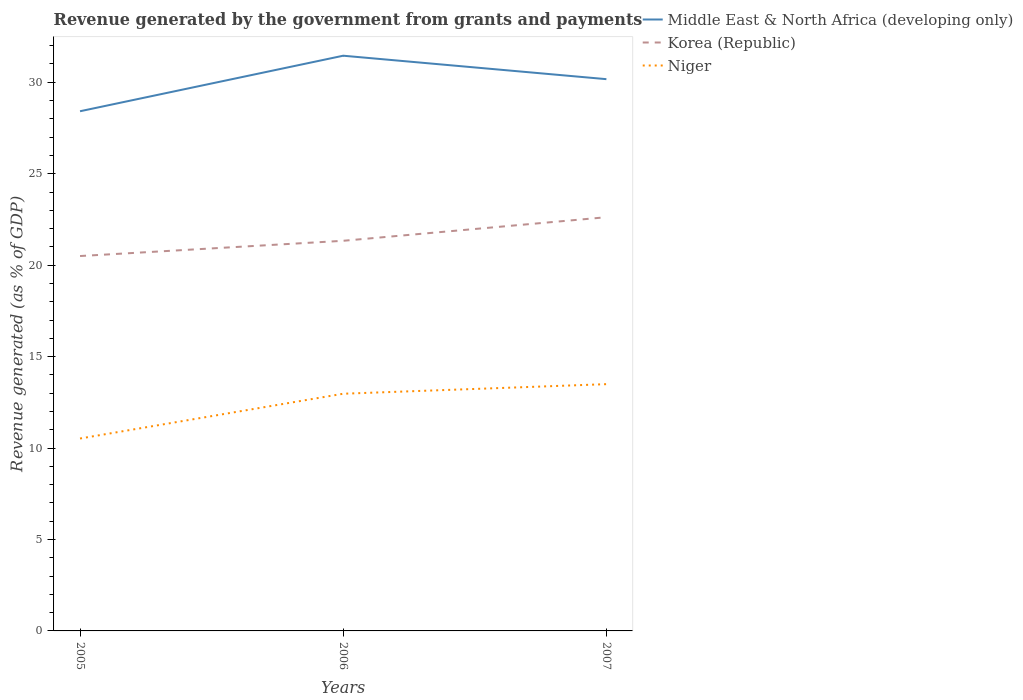Is the number of lines equal to the number of legend labels?
Offer a very short reply. Yes. Across all years, what is the maximum revenue generated by the government in Niger?
Your response must be concise. 10.52. What is the total revenue generated by the government in Korea (Republic) in the graph?
Your answer should be very brief. -1.29. What is the difference between the highest and the second highest revenue generated by the government in Korea (Republic)?
Your answer should be very brief. 2.12. How many lines are there?
Keep it short and to the point. 3. How many years are there in the graph?
Provide a succinct answer. 3. What is the difference between two consecutive major ticks on the Y-axis?
Provide a short and direct response. 5. Are the values on the major ticks of Y-axis written in scientific E-notation?
Offer a very short reply. No. Does the graph contain any zero values?
Your answer should be very brief. No. Does the graph contain grids?
Your answer should be compact. No. How are the legend labels stacked?
Provide a succinct answer. Vertical. What is the title of the graph?
Offer a very short reply. Revenue generated by the government from grants and payments. What is the label or title of the Y-axis?
Your answer should be compact. Revenue generated (as % of GDP). What is the Revenue generated (as % of GDP) of Middle East & North Africa (developing only) in 2005?
Your response must be concise. 28.42. What is the Revenue generated (as % of GDP) of Korea (Republic) in 2005?
Your answer should be very brief. 20.5. What is the Revenue generated (as % of GDP) of Niger in 2005?
Offer a terse response. 10.52. What is the Revenue generated (as % of GDP) of Middle East & North Africa (developing only) in 2006?
Your response must be concise. 31.45. What is the Revenue generated (as % of GDP) of Korea (Republic) in 2006?
Your answer should be very brief. 21.33. What is the Revenue generated (as % of GDP) of Niger in 2006?
Give a very brief answer. 12.97. What is the Revenue generated (as % of GDP) in Middle East & North Africa (developing only) in 2007?
Give a very brief answer. 30.17. What is the Revenue generated (as % of GDP) in Korea (Republic) in 2007?
Ensure brevity in your answer.  22.62. What is the Revenue generated (as % of GDP) of Niger in 2007?
Ensure brevity in your answer.  13.49. Across all years, what is the maximum Revenue generated (as % of GDP) in Middle East & North Africa (developing only)?
Provide a short and direct response. 31.45. Across all years, what is the maximum Revenue generated (as % of GDP) of Korea (Republic)?
Your answer should be compact. 22.62. Across all years, what is the maximum Revenue generated (as % of GDP) of Niger?
Offer a terse response. 13.49. Across all years, what is the minimum Revenue generated (as % of GDP) in Middle East & North Africa (developing only)?
Give a very brief answer. 28.42. Across all years, what is the minimum Revenue generated (as % of GDP) of Korea (Republic)?
Provide a short and direct response. 20.5. Across all years, what is the minimum Revenue generated (as % of GDP) in Niger?
Offer a terse response. 10.52. What is the total Revenue generated (as % of GDP) of Middle East & North Africa (developing only) in the graph?
Offer a terse response. 90.04. What is the total Revenue generated (as % of GDP) of Korea (Republic) in the graph?
Keep it short and to the point. 64.45. What is the total Revenue generated (as % of GDP) of Niger in the graph?
Your answer should be compact. 36.98. What is the difference between the Revenue generated (as % of GDP) of Middle East & North Africa (developing only) in 2005 and that in 2006?
Provide a short and direct response. -3.04. What is the difference between the Revenue generated (as % of GDP) in Korea (Republic) in 2005 and that in 2006?
Give a very brief answer. -0.83. What is the difference between the Revenue generated (as % of GDP) of Niger in 2005 and that in 2006?
Keep it short and to the point. -2.45. What is the difference between the Revenue generated (as % of GDP) in Middle East & North Africa (developing only) in 2005 and that in 2007?
Give a very brief answer. -1.75. What is the difference between the Revenue generated (as % of GDP) of Korea (Republic) in 2005 and that in 2007?
Your answer should be very brief. -2.12. What is the difference between the Revenue generated (as % of GDP) in Niger in 2005 and that in 2007?
Give a very brief answer. -2.97. What is the difference between the Revenue generated (as % of GDP) in Middle East & North Africa (developing only) in 2006 and that in 2007?
Provide a short and direct response. 1.28. What is the difference between the Revenue generated (as % of GDP) in Korea (Republic) in 2006 and that in 2007?
Your answer should be very brief. -1.29. What is the difference between the Revenue generated (as % of GDP) in Niger in 2006 and that in 2007?
Make the answer very short. -0.52. What is the difference between the Revenue generated (as % of GDP) of Middle East & North Africa (developing only) in 2005 and the Revenue generated (as % of GDP) of Korea (Republic) in 2006?
Your answer should be compact. 7.08. What is the difference between the Revenue generated (as % of GDP) in Middle East & North Africa (developing only) in 2005 and the Revenue generated (as % of GDP) in Niger in 2006?
Keep it short and to the point. 15.45. What is the difference between the Revenue generated (as % of GDP) of Korea (Republic) in 2005 and the Revenue generated (as % of GDP) of Niger in 2006?
Keep it short and to the point. 7.53. What is the difference between the Revenue generated (as % of GDP) in Middle East & North Africa (developing only) in 2005 and the Revenue generated (as % of GDP) in Korea (Republic) in 2007?
Provide a short and direct response. 5.79. What is the difference between the Revenue generated (as % of GDP) of Middle East & North Africa (developing only) in 2005 and the Revenue generated (as % of GDP) of Niger in 2007?
Provide a short and direct response. 14.92. What is the difference between the Revenue generated (as % of GDP) of Korea (Republic) in 2005 and the Revenue generated (as % of GDP) of Niger in 2007?
Your answer should be very brief. 7.01. What is the difference between the Revenue generated (as % of GDP) in Middle East & North Africa (developing only) in 2006 and the Revenue generated (as % of GDP) in Korea (Republic) in 2007?
Ensure brevity in your answer.  8.83. What is the difference between the Revenue generated (as % of GDP) in Middle East & North Africa (developing only) in 2006 and the Revenue generated (as % of GDP) in Niger in 2007?
Offer a terse response. 17.96. What is the difference between the Revenue generated (as % of GDP) in Korea (Republic) in 2006 and the Revenue generated (as % of GDP) in Niger in 2007?
Offer a terse response. 7.84. What is the average Revenue generated (as % of GDP) of Middle East & North Africa (developing only) per year?
Keep it short and to the point. 30.01. What is the average Revenue generated (as % of GDP) of Korea (Republic) per year?
Provide a short and direct response. 21.48. What is the average Revenue generated (as % of GDP) of Niger per year?
Offer a terse response. 12.33. In the year 2005, what is the difference between the Revenue generated (as % of GDP) in Middle East & North Africa (developing only) and Revenue generated (as % of GDP) in Korea (Republic)?
Ensure brevity in your answer.  7.92. In the year 2005, what is the difference between the Revenue generated (as % of GDP) in Middle East & North Africa (developing only) and Revenue generated (as % of GDP) in Niger?
Give a very brief answer. 17.89. In the year 2005, what is the difference between the Revenue generated (as % of GDP) in Korea (Republic) and Revenue generated (as % of GDP) in Niger?
Keep it short and to the point. 9.98. In the year 2006, what is the difference between the Revenue generated (as % of GDP) in Middle East & North Africa (developing only) and Revenue generated (as % of GDP) in Korea (Republic)?
Your answer should be very brief. 10.12. In the year 2006, what is the difference between the Revenue generated (as % of GDP) of Middle East & North Africa (developing only) and Revenue generated (as % of GDP) of Niger?
Provide a short and direct response. 18.48. In the year 2006, what is the difference between the Revenue generated (as % of GDP) of Korea (Republic) and Revenue generated (as % of GDP) of Niger?
Your response must be concise. 8.36. In the year 2007, what is the difference between the Revenue generated (as % of GDP) in Middle East & North Africa (developing only) and Revenue generated (as % of GDP) in Korea (Republic)?
Keep it short and to the point. 7.55. In the year 2007, what is the difference between the Revenue generated (as % of GDP) in Middle East & North Africa (developing only) and Revenue generated (as % of GDP) in Niger?
Offer a terse response. 16.68. In the year 2007, what is the difference between the Revenue generated (as % of GDP) in Korea (Republic) and Revenue generated (as % of GDP) in Niger?
Make the answer very short. 9.13. What is the ratio of the Revenue generated (as % of GDP) of Middle East & North Africa (developing only) in 2005 to that in 2006?
Provide a succinct answer. 0.9. What is the ratio of the Revenue generated (as % of GDP) of Korea (Republic) in 2005 to that in 2006?
Provide a succinct answer. 0.96. What is the ratio of the Revenue generated (as % of GDP) in Niger in 2005 to that in 2006?
Offer a terse response. 0.81. What is the ratio of the Revenue generated (as % of GDP) in Middle East & North Africa (developing only) in 2005 to that in 2007?
Offer a very short reply. 0.94. What is the ratio of the Revenue generated (as % of GDP) of Korea (Republic) in 2005 to that in 2007?
Offer a very short reply. 0.91. What is the ratio of the Revenue generated (as % of GDP) of Niger in 2005 to that in 2007?
Keep it short and to the point. 0.78. What is the ratio of the Revenue generated (as % of GDP) of Middle East & North Africa (developing only) in 2006 to that in 2007?
Provide a short and direct response. 1.04. What is the ratio of the Revenue generated (as % of GDP) of Korea (Republic) in 2006 to that in 2007?
Give a very brief answer. 0.94. What is the ratio of the Revenue generated (as % of GDP) in Niger in 2006 to that in 2007?
Provide a short and direct response. 0.96. What is the difference between the highest and the second highest Revenue generated (as % of GDP) of Middle East & North Africa (developing only)?
Give a very brief answer. 1.28. What is the difference between the highest and the second highest Revenue generated (as % of GDP) of Korea (Republic)?
Provide a short and direct response. 1.29. What is the difference between the highest and the second highest Revenue generated (as % of GDP) of Niger?
Provide a short and direct response. 0.52. What is the difference between the highest and the lowest Revenue generated (as % of GDP) of Middle East & North Africa (developing only)?
Your answer should be compact. 3.04. What is the difference between the highest and the lowest Revenue generated (as % of GDP) of Korea (Republic)?
Your answer should be compact. 2.12. What is the difference between the highest and the lowest Revenue generated (as % of GDP) of Niger?
Provide a succinct answer. 2.97. 